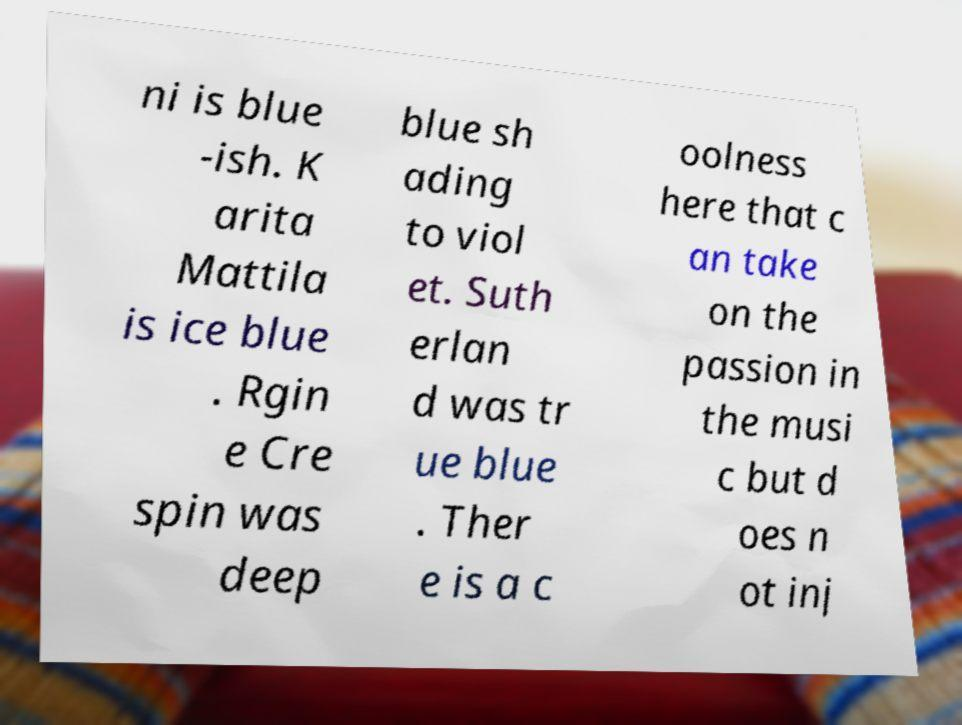Could you assist in decoding the text presented in this image and type it out clearly? ni is blue -ish. K arita Mattila is ice blue . Rgin e Cre spin was deep blue sh ading to viol et. Suth erlan d was tr ue blue . Ther e is a c oolness here that c an take on the passion in the musi c but d oes n ot inj 